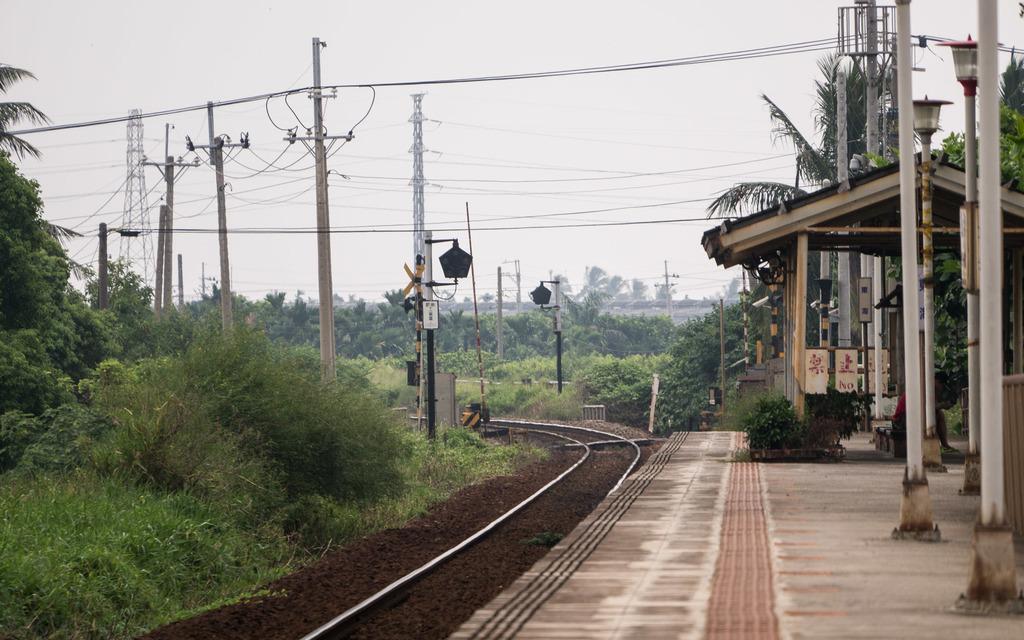How would you summarize this image in a sentence or two? In this image I can see there is a railway track and there are poles at right side, there are few electric poles on the left side with wires. There are a few plants and trees at left side and in the backdrop, I can see there are few more trees and the sky is clear. 